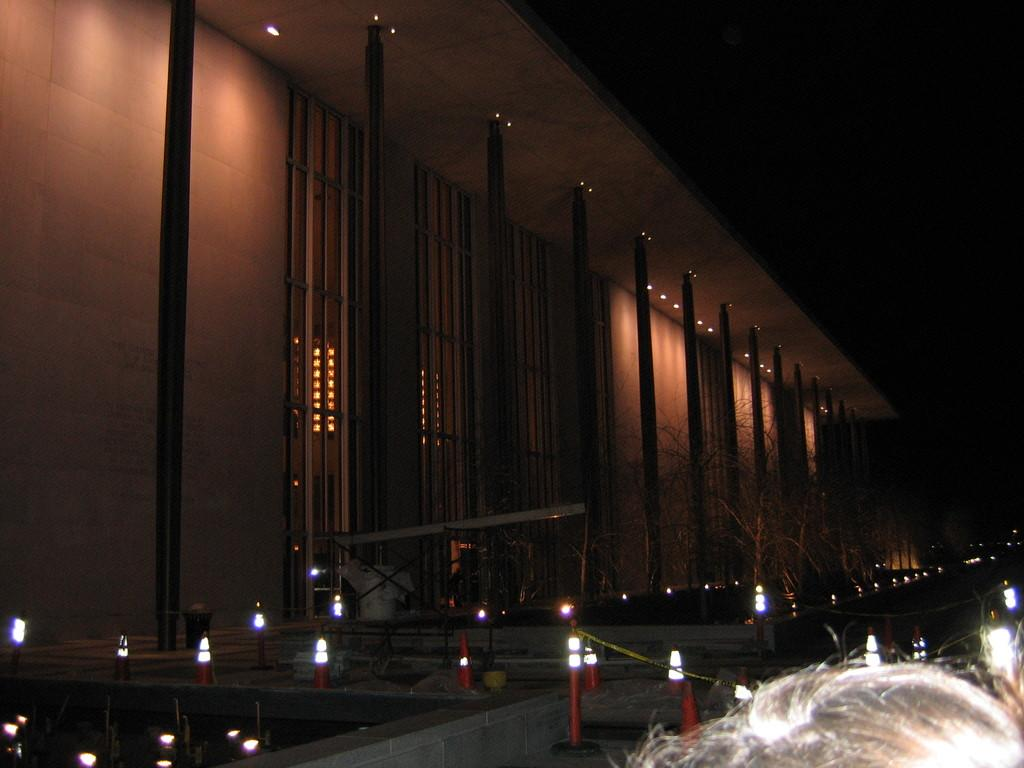What architectural feature can be seen in the image? There are pillars in the image. Where are the pillars located in relation to other structures? The pillars are in front of a wall. What type of lighting is present at the bottom of the image? There are lights at the bottom of the image. How many roots can be seen growing from the pillars in the image? There are no roots visible in the image, as the pillars are not plants or trees. 